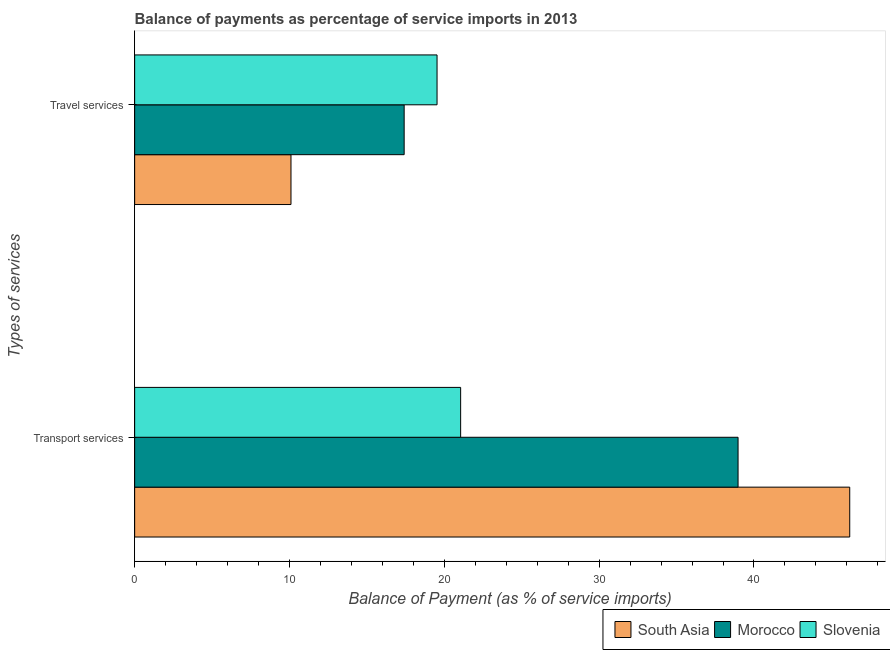How many different coloured bars are there?
Provide a short and direct response. 3. Are the number of bars on each tick of the Y-axis equal?
Your answer should be very brief. Yes. How many bars are there on the 2nd tick from the top?
Provide a short and direct response. 3. What is the label of the 2nd group of bars from the top?
Keep it short and to the point. Transport services. What is the balance of payments of transport services in South Asia?
Offer a very short reply. 46.18. Across all countries, what is the maximum balance of payments of transport services?
Give a very brief answer. 46.18. Across all countries, what is the minimum balance of payments of travel services?
Offer a very short reply. 10.1. In which country was the balance of payments of travel services maximum?
Give a very brief answer. Slovenia. In which country was the balance of payments of transport services minimum?
Give a very brief answer. Slovenia. What is the total balance of payments of travel services in the graph?
Offer a very short reply. 47.03. What is the difference between the balance of payments of travel services in Slovenia and that in Morocco?
Make the answer very short. 2.12. What is the difference between the balance of payments of transport services in Slovenia and the balance of payments of travel services in Morocco?
Make the answer very short. 3.65. What is the average balance of payments of travel services per country?
Give a very brief answer. 15.68. What is the difference between the balance of payments of travel services and balance of payments of transport services in Morocco?
Keep it short and to the point. -21.57. In how many countries, is the balance of payments of travel services greater than 46 %?
Your answer should be compact. 0. What is the ratio of the balance of payments of transport services in Morocco to that in South Asia?
Provide a short and direct response. 0.84. Is the balance of payments of transport services in Slovenia less than that in Morocco?
Offer a terse response. Yes. In how many countries, is the balance of payments of travel services greater than the average balance of payments of travel services taken over all countries?
Keep it short and to the point. 2. What does the 3rd bar from the top in Travel services represents?
Your response must be concise. South Asia. What does the 2nd bar from the bottom in Travel services represents?
Provide a succinct answer. Morocco. Are all the bars in the graph horizontal?
Provide a succinct answer. Yes. How many countries are there in the graph?
Your response must be concise. 3. What is the title of the graph?
Keep it short and to the point. Balance of payments as percentage of service imports in 2013. What is the label or title of the X-axis?
Your response must be concise. Balance of Payment (as % of service imports). What is the label or title of the Y-axis?
Offer a terse response. Types of services. What is the Balance of Payment (as % of service imports) of South Asia in Transport services?
Offer a terse response. 46.18. What is the Balance of Payment (as % of service imports) in Morocco in Transport services?
Your answer should be compact. 38.97. What is the Balance of Payment (as % of service imports) of Slovenia in Transport services?
Provide a succinct answer. 21.05. What is the Balance of Payment (as % of service imports) of South Asia in Travel services?
Provide a succinct answer. 10.1. What is the Balance of Payment (as % of service imports) of Morocco in Travel services?
Offer a terse response. 17.41. What is the Balance of Payment (as % of service imports) in Slovenia in Travel services?
Offer a very short reply. 19.53. Across all Types of services, what is the maximum Balance of Payment (as % of service imports) of South Asia?
Give a very brief answer. 46.18. Across all Types of services, what is the maximum Balance of Payment (as % of service imports) of Morocco?
Make the answer very short. 38.97. Across all Types of services, what is the maximum Balance of Payment (as % of service imports) of Slovenia?
Provide a succinct answer. 21.05. Across all Types of services, what is the minimum Balance of Payment (as % of service imports) of South Asia?
Your answer should be very brief. 10.1. Across all Types of services, what is the minimum Balance of Payment (as % of service imports) in Morocco?
Keep it short and to the point. 17.41. Across all Types of services, what is the minimum Balance of Payment (as % of service imports) of Slovenia?
Provide a short and direct response. 19.53. What is the total Balance of Payment (as % of service imports) of South Asia in the graph?
Offer a terse response. 56.28. What is the total Balance of Payment (as % of service imports) in Morocco in the graph?
Your answer should be compact. 56.38. What is the total Balance of Payment (as % of service imports) in Slovenia in the graph?
Give a very brief answer. 40.59. What is the difference between the Balance of Payment (as % of service imports) of South Asia in Transport services and that in Travel services?
Keep it short and to the point. 36.09. What is the difference between the Balance of Payment (as % of service imports) in Morocco in Transport services and that in Travel services?
Your answer should be compact. 21.57. What is the difference between the Balance of Payment (as % of service imports) in Slovenia in Transport services and that in Travel services?
Your response must be concise. 1.52. What is the difference between the Balance of Payment (as % of service imports) of South Asia in Transport services and the Balance of Payment (as % of service imports) of Morocco in Travel services?
Provide a short and direct response. 28.78. What is the difference between the Balance of Payment (as % of service imports) of South Asia in Transport services and the Balance of Payment (as % of service imports) of Slovenia in Travel services?
Ensure brevity in your answer.  26.65. What is the difference between the Balance of Payment (as % of service imports) in Morocco in Transport services and the Balance of Payment (as % of service imports) in Slovenia in Travel services?
Ensure brevity in your answer.  19.44. What is the average Balance of Payment (as % of service imports) of South Asia per Types of services?
Ensure brevity in your answer.  28.14. What is the average Balance of Payment (as % of service imports) in Morocco per Types of services?
Offer a terse response. 28.19. What is the average Balance of Payment (as % of service imports) of Slovenia per Types of services?
Keep it short and to the point. 20.29. What is the difference between the Balance of Payment (as % of service imports) of South Asia and Balance of Payment (as % of service imports) of Morocco in Transport services?
Keep it short and to the point. 7.21. What is the difference between the Balance of Payment (as % of service imports) of South Asia and Balance of Payment (as % of service imports) of Slovenia in Transport services?
Ensure brevity in your answer.  25.13. What is the difference between the Balance of Payment (as % of service imports) in Morocco and Balance of Payment (as % of service imports) in Slovenia in Transport services?
Provide a short and direct response. 17.92. What is the difference between the Balance of Payment (as % of service imports) of South Asia and Balance of Payment (as % of service imports) of Morocco in Travel services?
Your response must be concise. -7.31. What is the difference between the Balance of Payment (as % of service imports) of South Asia and Balance of Payment (as % of service imports) of Slovenia in Travel services?
Provide a short and direct response. -9.43. What is the difference between the Balance of Payment (as % of service imports) in Morocco and Balance of Payment (as % of service imports) in Slovenia in Travel services?
Keep it short and to the point. -2.12. What is the ratio of the Balance of Payment (as % of service imports) in South Asia in Transport services to that in Travel services?
Make the answer very short. 4.57. What is the ratio of the Balance of Payment (as % of service imports) in Morocco in Transport services to that in Travel services?
Offer a terse response. 2.24. What is the ratio of the Balance of Payment (as % of service imports) of Slovenia in Transport services to that in Travel services?
Keep it short and to the point. 1.08. What is the difference between the highest and the second highest Balance of Payment (as % of service imports) in South Asia?
Ensure brevity in your answer.  36.09. What is the difference between the highest and the second highest Balance of Payment (as % of service imports) in Morocco?
Keep it short and to the point. 21.57. What is the difference between the highest and the second highest Balance of Payment (as % of service imports) of Slovenia?
Make the answer very short. 1.52. What is the difference between the highest and the lowest Balance of Payment (as % of service imports) of South Asia?
Your answer should be very brief. 36.09. What is the difference between the highest and the lowest Balance of Payment (as % of service imports) in Morocco?
Make the answer very short. 21.57. What is the difference between the highest and the lowest Balance of Payment (as % of service imports) in Slovenia?
Ensure brevity in your answer.  1.52. 